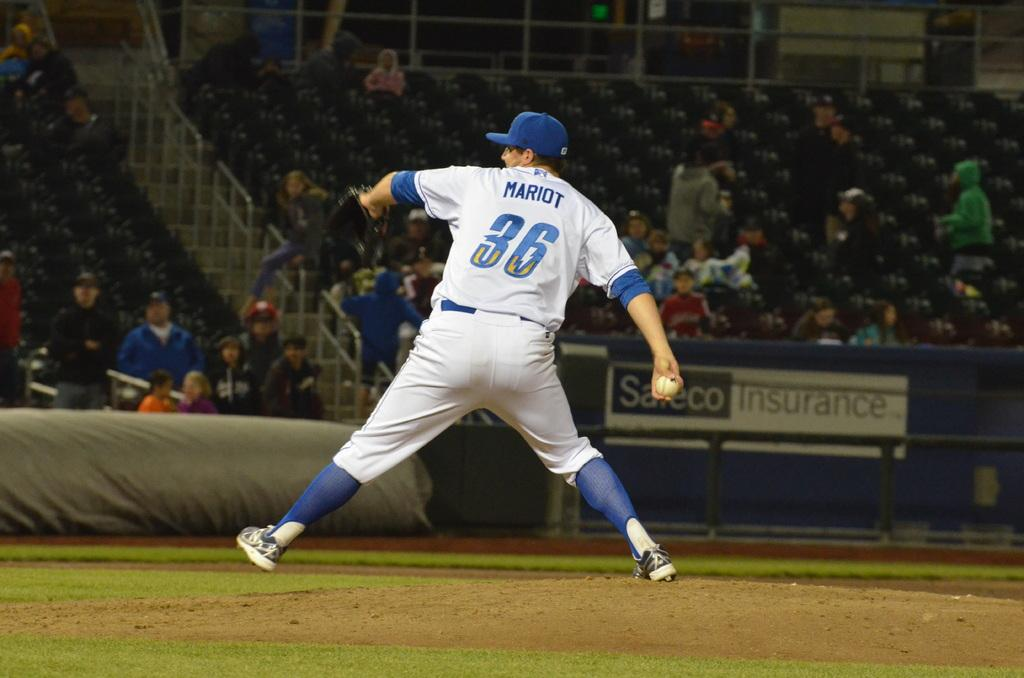<image>
Offer a succinct explanation of the picture presented. Baseball player wearing number 36 pitching the ball. 